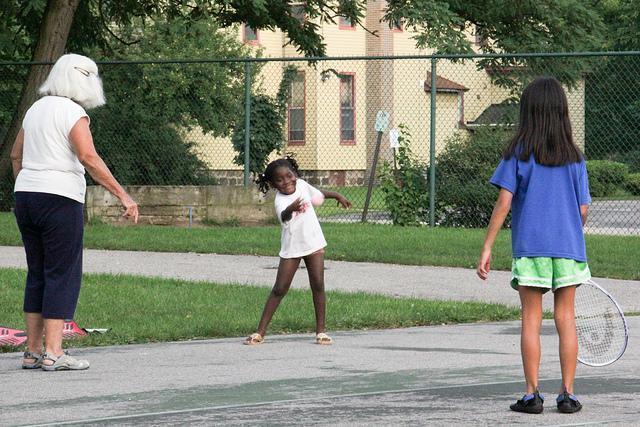What type of sporting area are girls most likely playing on?
Indicate the correct response by choosing from the four available options to answer the question.
Options: Tennis court, soccer field, basketball stadium, baseball diamond. Tennis court. 